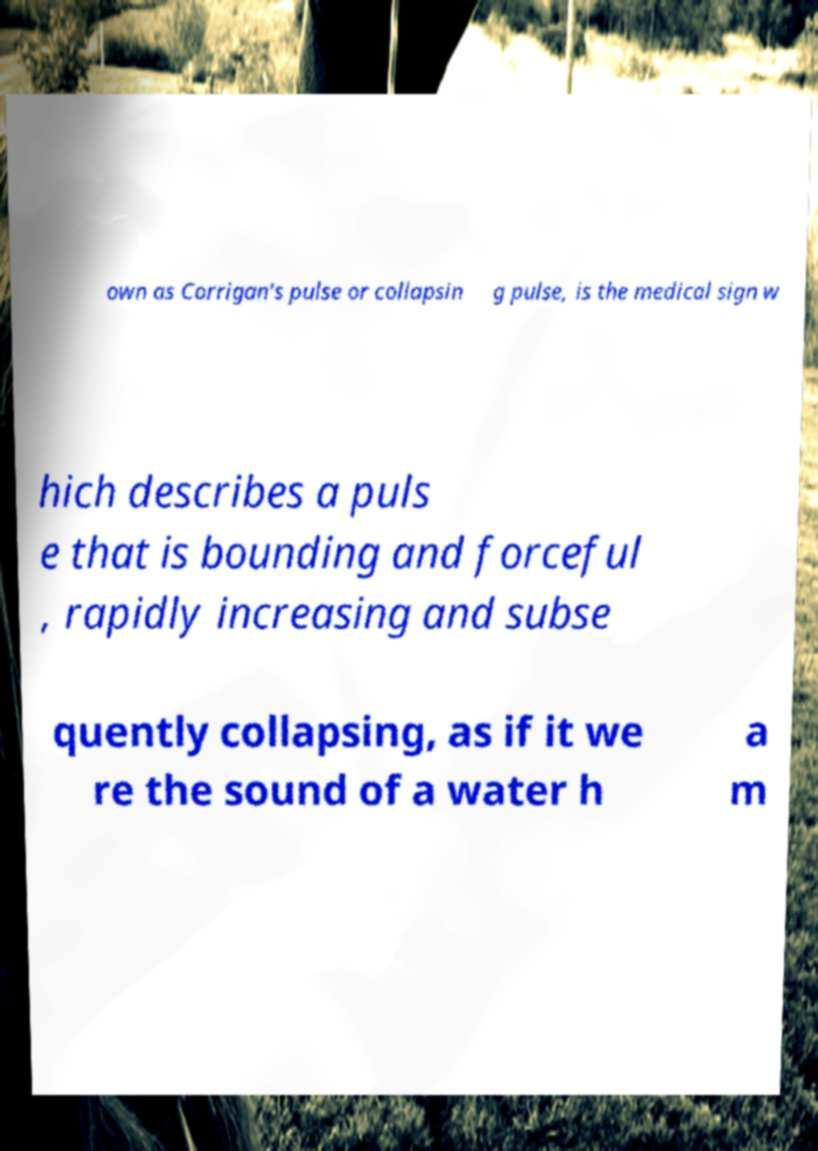Please identify and transcribe the text found in this image. own as Corrigan's pulse or collapsin g pulse, is the medical sign w hich describes a puls e that is bounding and forceful , rapidly increasing and subse quently collapsing, as if it we re the sound of a water h a m 